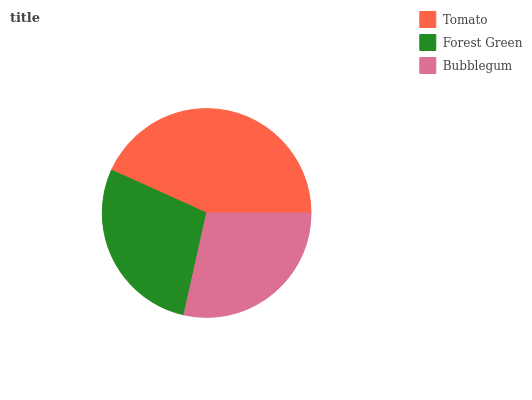Is Forest Green the minimum?
Answer yes or no. Yes. Is Tomato the maximum?
Answer yes or no. Yes. Is Bubblegum the minimum?
Answer yes or no. No. Is Bubblegum the maximum?
Answer yes or no. No. Is Bubblegum greater than Forest Green?
Answer yes or no. Yes. Is Forest Green less than Bubblegum?
Answer yes or no. Yes. Is Forest Green greater than Bubblegum?
Answer yes or no. No. Is Bubblegum less than Forest Green?
Answer yes or no. No. Is Bubblegum the high median?
Answer yes or no. Yes. Is Bubblegum the low median?
Answer yes or no. Yes. Is Forest Green the high median?
Answer yes or no. No. Is Tomato the low median?
Answer yes or no. No. 